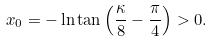Convert formula to latex. <formula><loc_0><loc_0><loc_500><loc_500>x _ { 0 } = - \ln \tan \left ( \frac { \kappa } { 8 } - \frac { \pi } { 4 } \right ) > 0 .</formula> 